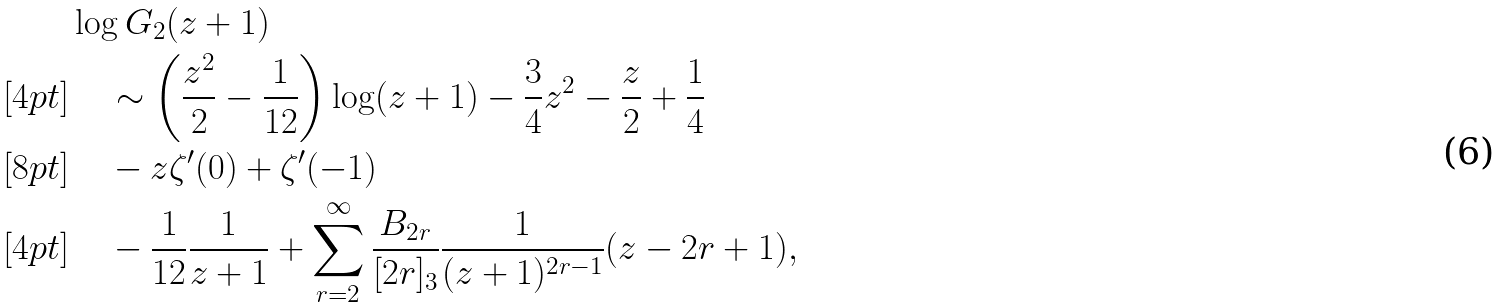<formula> <loc_0><loc_0><loc_500><loc_500>& \log G _ { 2 } ( z + 1 ) \\ [ 4 p t ] & \quad \sim \left ( \frac { z ^ { 2 } } { 2 } - \frac { 1 } { 1 2 } \right ) \log ( z + 1 ) - \frac { 3 } { 4 } z ^ { 2 } - \frac { z } { 2 } + \frac { 1 } { 4 } \\ [ 8 p t ] & \quad - z \zeta ^ { \prime } ( 0 ) + \zeta ^ { \prime } ( - 1 ) \\ [ 4 p t ] & \quad - \frac { 1 } { 1 2 } \frac { 1 } { z + 1 } + \sum _ { r = 2 } ^ { \infty } \frac { B _ { 2 r } } { [ 2 r ] _ { 3 } } \frac { 1 } { ( z + 1 ) ^ { 2 r - 1 } } ( z - 2 r + 1 ) ,</formula> 